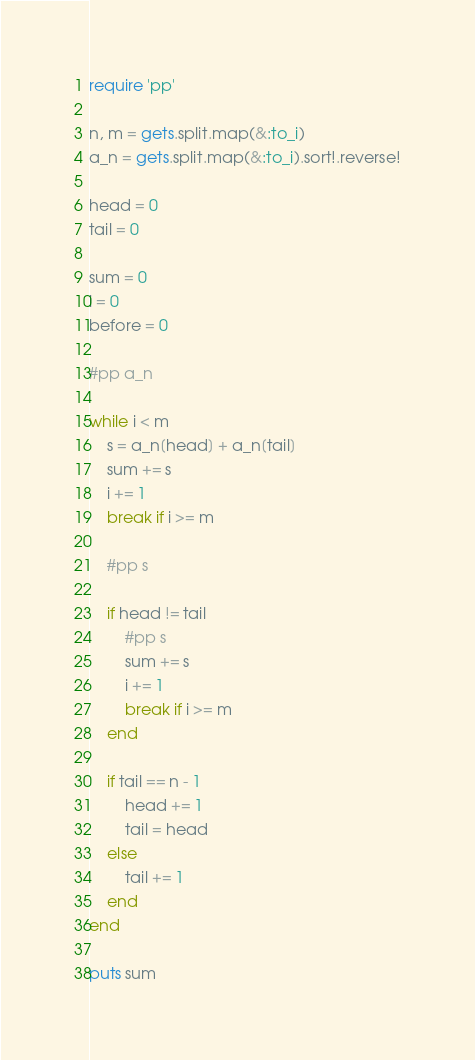<code> <loc_0><loc_0><loc_500><loc_500><_Ruby_>require 'pp'

n, m = gets.split.map(&:to_i)
a_n = gets.split.map(&:to_i).sort!.reverse!

head = 0
tail = 0

sum = 0
i = 0
before = 0

#pp a_n

while i < m
    s = a_n[head] + a_n[tail]
    sum += s
    i += 1
    break if i >= m

    #pp s

    if head != tail
        #pp s
        sum += s
        i += 1
        break if i >= m
    end

    if tail == n - 1
        head += 1
        tail = head
    else
        tail += 1
    end
end

puts sum
</code> 